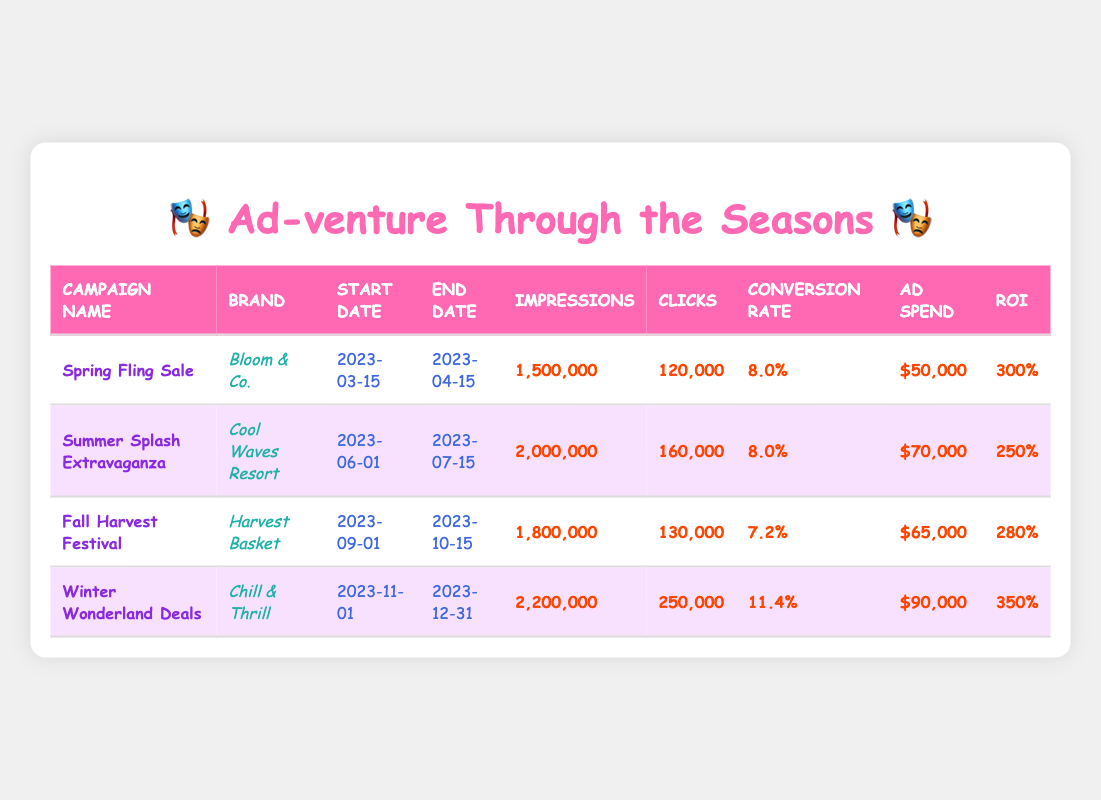What is the conversion rate of the Winter Wonderland Deals campaign? The Winter Wonderland Deals campaign has a conversion rate listed directly in the table as 11.4%.
Answer: 11.4% Which campaign had the highest ROI? Looking through the ROI column, Winter Wonderland Deals has the highest ROI at 350%.
Answer: 350% What is the total ad spend for all campaigns combined? By adding the ad spend values: 50000 + 70000 + 65000 + 90000 = 285000.
Answer: 285000 Is the conversion rate for Summer Splash Extravaganza higher than the Fall Harvest Festival? The conversion rate for Summer Splash Extravaganza is 8.0% and for Fall Harvest Festival it is 7.2%. Since 8.0% is greater than 7.2%, the statement is true.
Answer: Yes How many clicks did the Spring Fling Sale campaign generate compared to Winter Wonderland Deals? The Spring Fling Sale campaign generated 120000 clicks while Winter Wonderland Deals generated 250000 clicks. Comparing these values (250000 > 120000), Winter Wonderland Deals had more clicks.
Answer: Winter Wonderland Deals had more clicks Which season's campaign had the most impressions and by how much? The Winter Wonderland Deals campaign had the most impressions at 2200000, while the Spring Fling Sale had 1500000 impressions. The difference is 2200000 - 1500000 = 700000.
Answer: 700000 What is the average conversion rate across all the campaigns? The conversion rates are 8.0, 8.0, 7.2, and 11.4. To find the average: (8.0 + 8.0 + 7.2 + 11.4) / 4 = 34.6 / 4 = 8.65.
Answer: 8.65 Did Bloom & Co. have a higher ad spend than Harvest Basket? Bloom & Co. had an ad spend of 50000 while Harvest Basket had 65000. Since 50000 is less than 65000, the statement is false.
Answer: No What is the difference in the number of clicks between the campaigns with the highest and lowest clicks? Winter Wonderland Deals had 250000 clicks and Spring Fling Sale had 120000 clicks. The difference is 250000 - 120000 = 130000.
Answer: 130000 